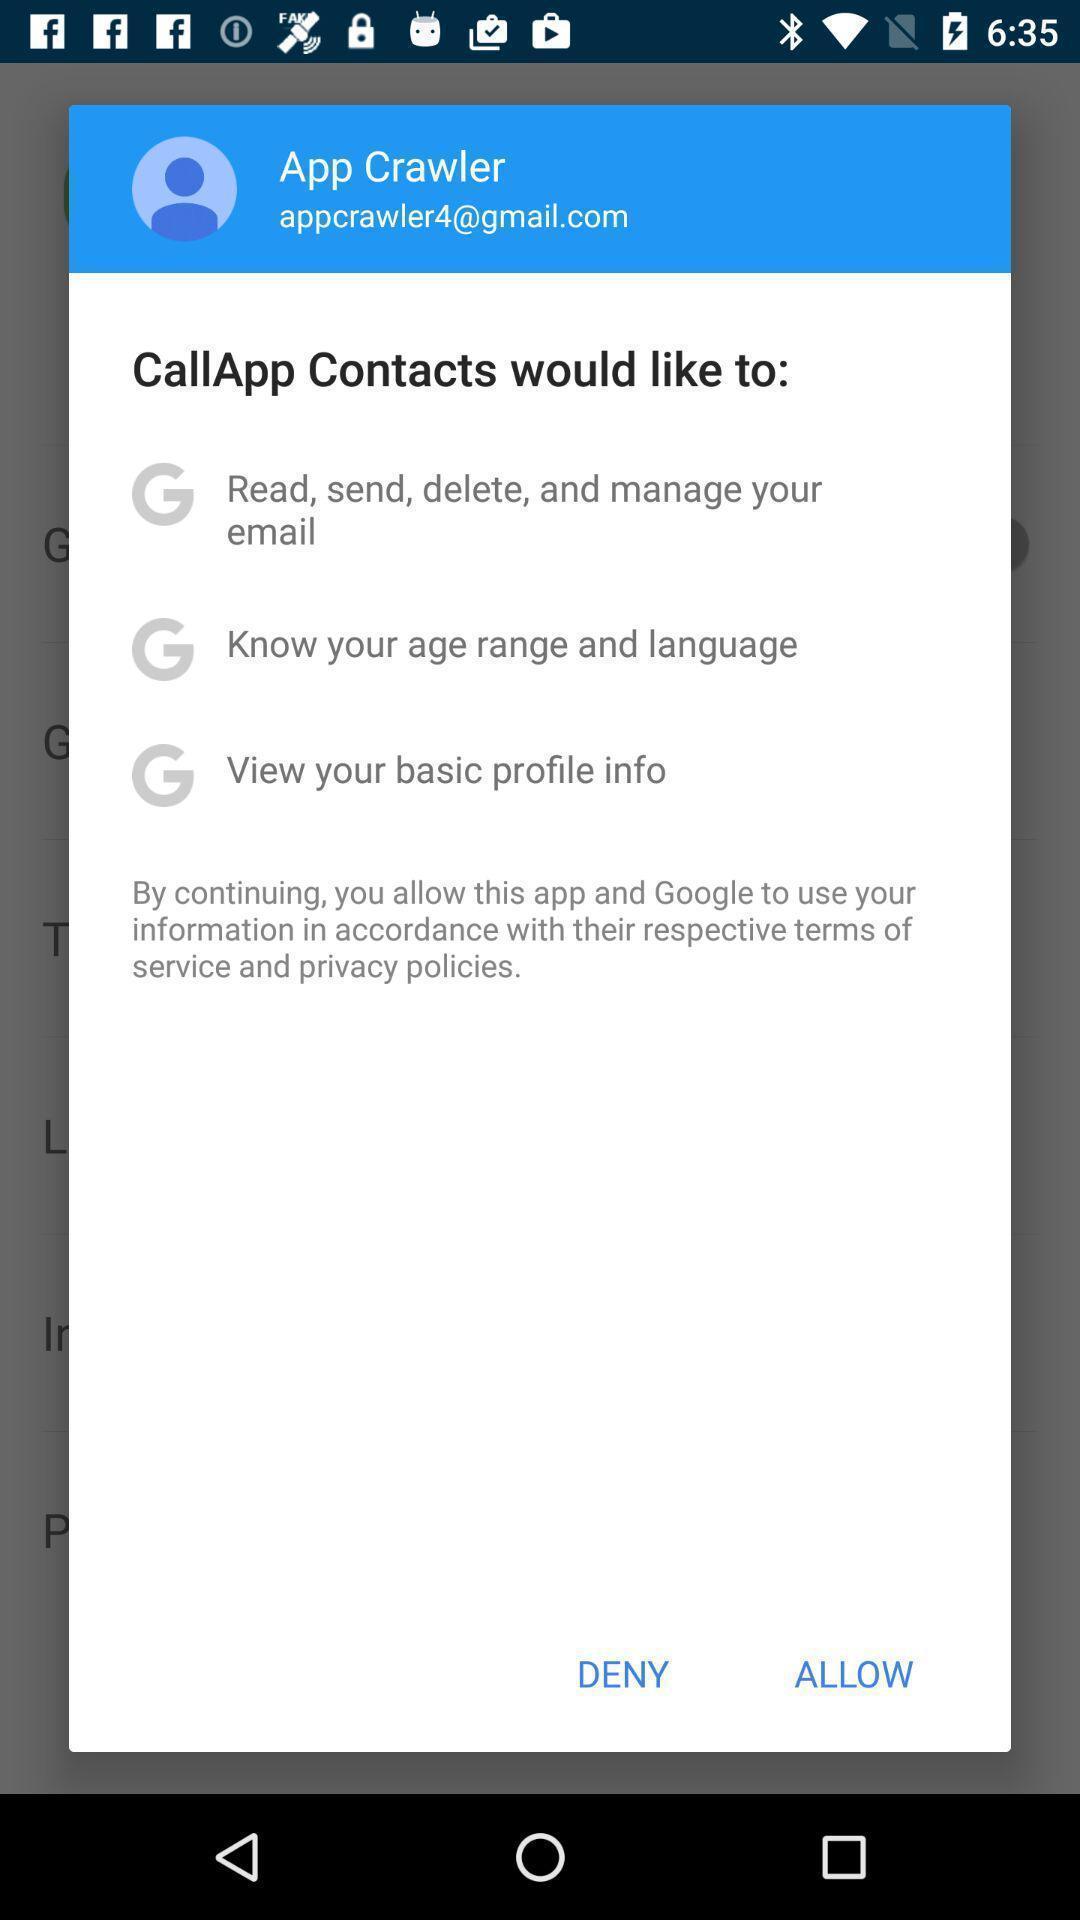Describe the visual elements of this screenshot. Pop-up shows callapp contact option in an contact application. 